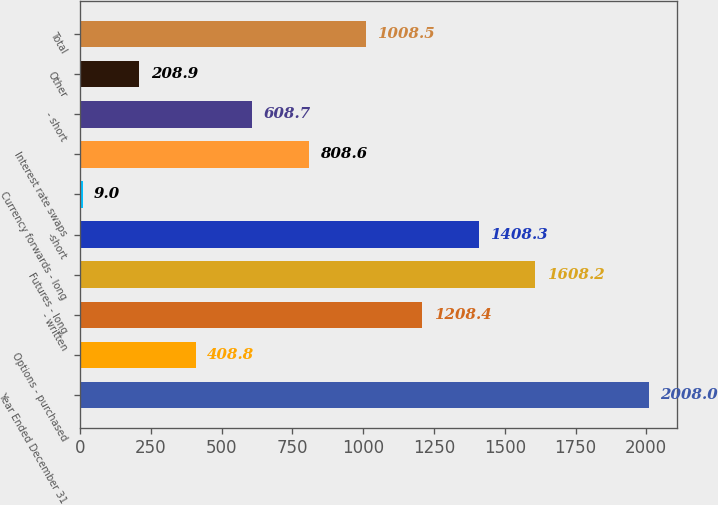Convert chart to OTSL. <chart><loc_0><loc_0><loc_500><loc_500><bar_chart><fcel>Year Ended December 31<fcel>Options - purchased<fcel>- written<fcel>Futures - long<fcel>-short<fcel>Currency forwards - long<fcel>Interest rate swaps<fcel>- short<fcel>Other<fcel>Total<nl><fcel>2008<fcel>408.8<fcel>1208.4<fcel>1608.2<fcel>1408.3<fcel>9<fcel>808.6<fcel>608.7<fcel>208.9<fcel>1008.5<nl></chart> 